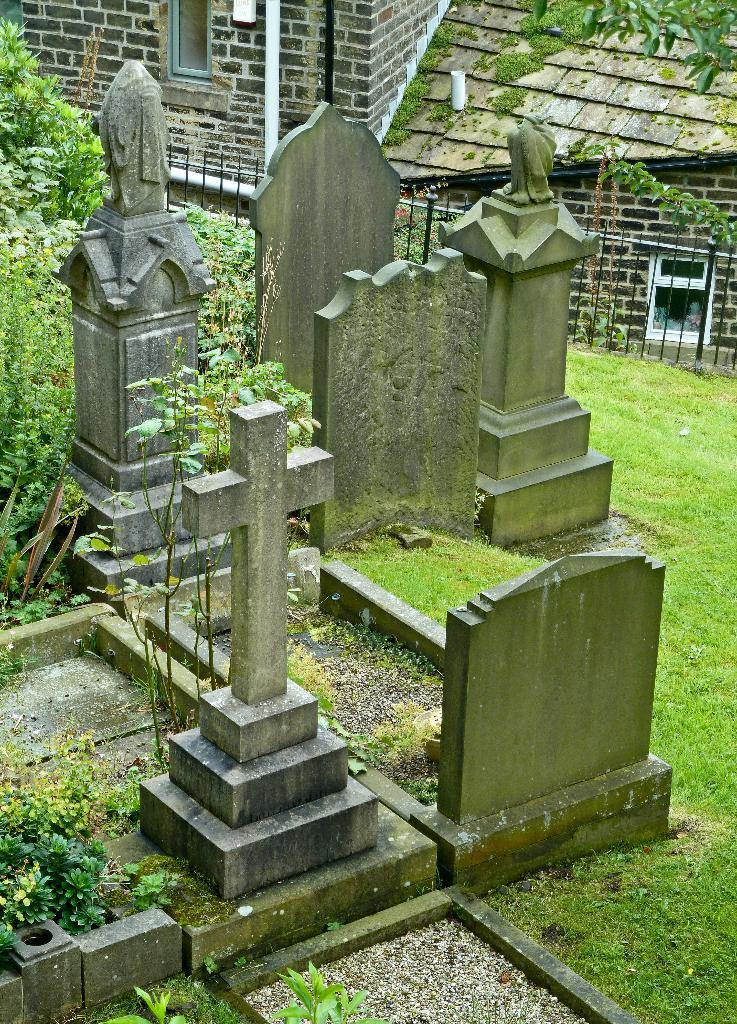What can be seen on the ground in the image? There are graves and plants on the ground in the image. What type of vegetation is present on the ground? There is grass on the ground in the image. What is the purpose of the railing in the image? The railing is visible in the image, but its purpose is not explicitly stated. What structures can be seen behind the railing? There are buildings behind the railing in the image. How many times did the arch fall in the image? There is no arch present in the image, so it cannot be determined how many times it may have fallen. 